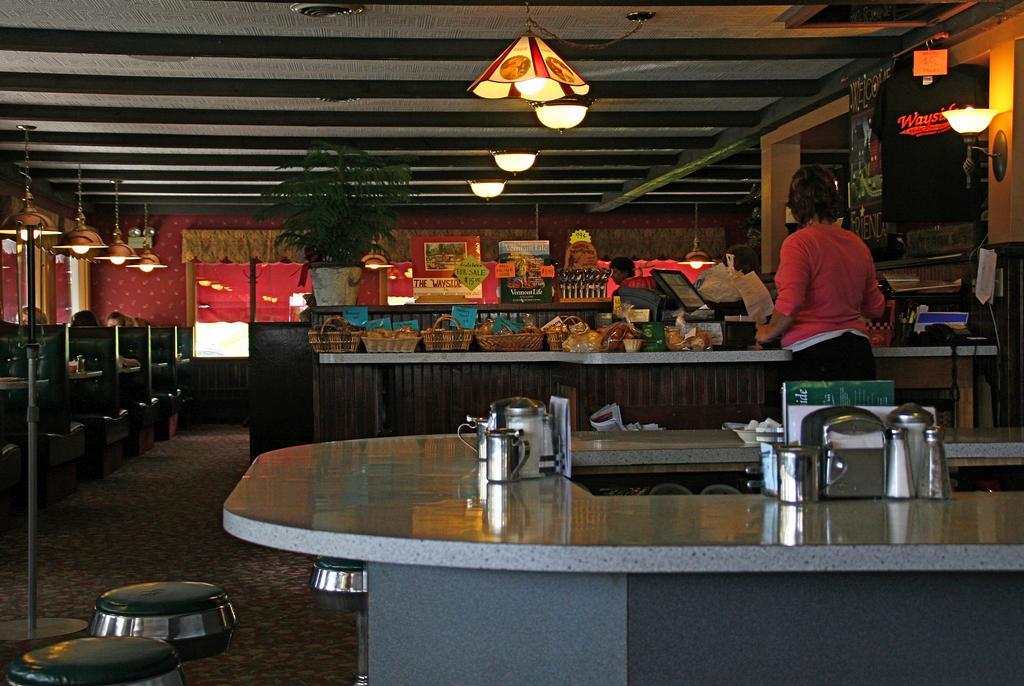Please provide a concise description of this image. In this picture we can see few baskets, bottles, jugs, frames and other things on the countertops, beside the countertop we can see few persons, in the background we can see few lights and a plant. 